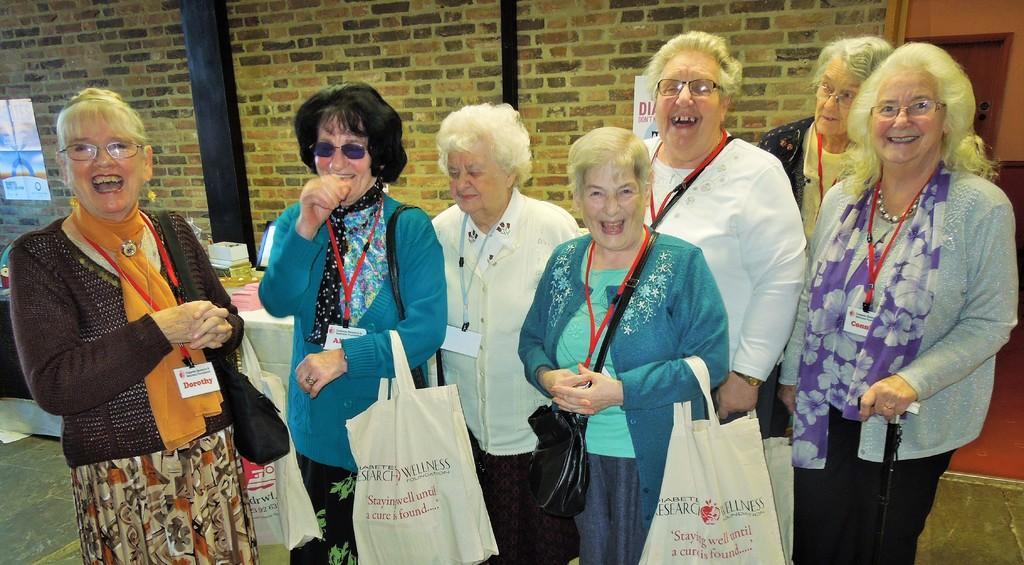Describe this image in one or two sentences. In this image at front there are women's standing on the floor and they are laughing. Behind them there is table and some objects were placed on it. At the back side there is a wall. 